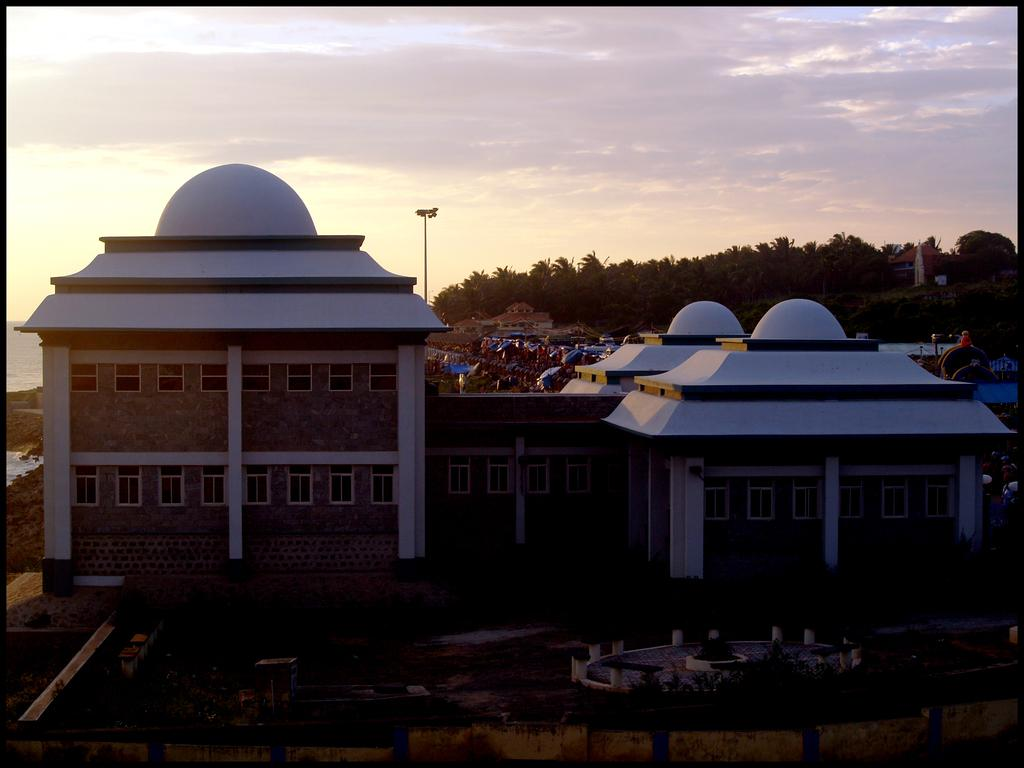What type of structures can be seen in the image? There are buildings in the image. What is the color of the buildings? The buildings are white. What other types of structures can be seen in the background of the image? There are houses in the background of the image. What natural elements are present in the background of the image? Trees, a light pole, clouds, and the sky are visible in the background of the image. How many pieces of chalk are lying on the ground in the image? There is no chalk present in the image. What type of stone can be seen in the image? There is no stone present in the image. 